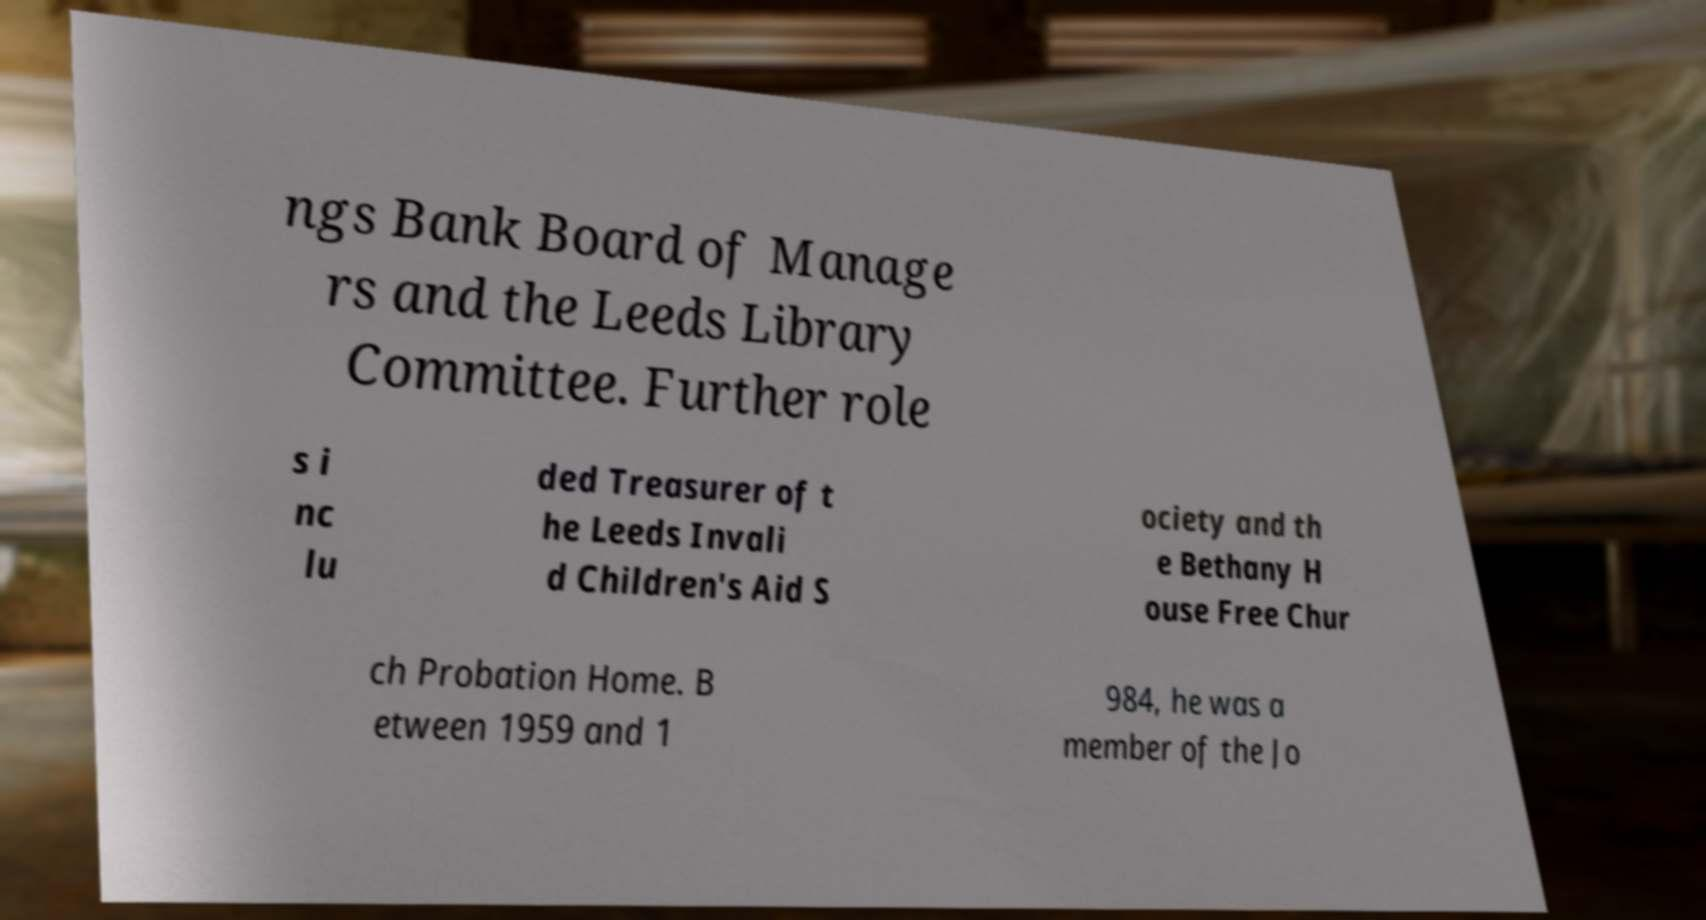Please read and relay the text visible in this image. What does it say? ngs Bank Board of Manage rs and the Leeds Library Committee. Further role s i nc lu ded Treasurer of t he Leeds Invali d Children's Aid S ociety and th e Bethany H ouse Free Chur ch Probation Home. B etween 1959 and 1 984, he was a member of the Jo 